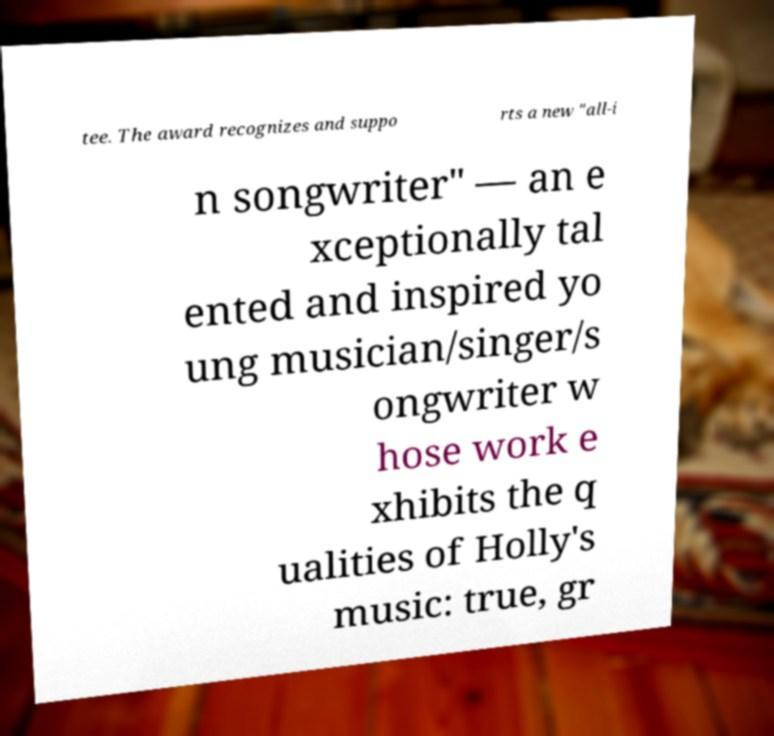Can you read and provide the text displayed in the image?This photo seems to have some interesting text. Can you extract and type it out for me? tee. The award recognizes and suppo rts a new "all-i n songwriter" — an e xceptionally tal ented and inspired yo ung musician/singer/s ongwriter w hose work e xhibits the q ualities of Holly's music: true, gr 